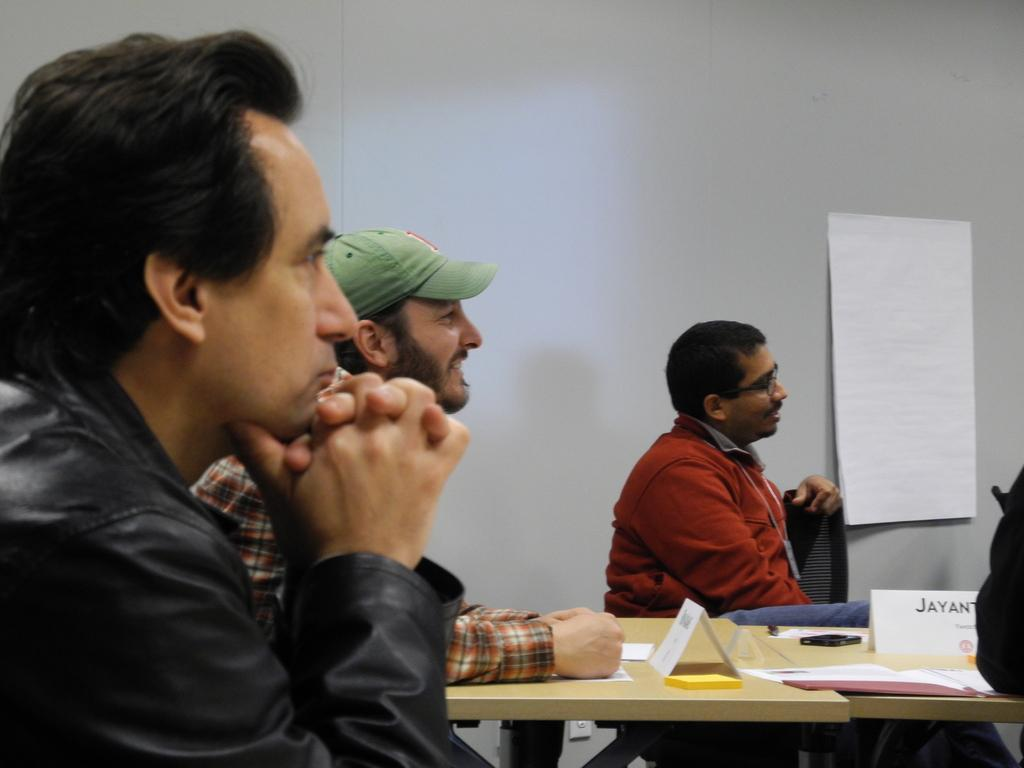How many men are in the image? There are three men in the image. What are the men doing in the image? The men are sitting on a chair. What is in front of the men? There is a table in front of the men. What items can be seen on the table? Notepads, papers, and mobile phones are on the table. What is on the wall in the image? There is a chart on the wall. Is there a ball hanging from the ceiling in the image? No, there is no ball hanging from the ceiling in the image. Can you see any cobwebs in the image? No, there are no cobwebs visible in the image. 